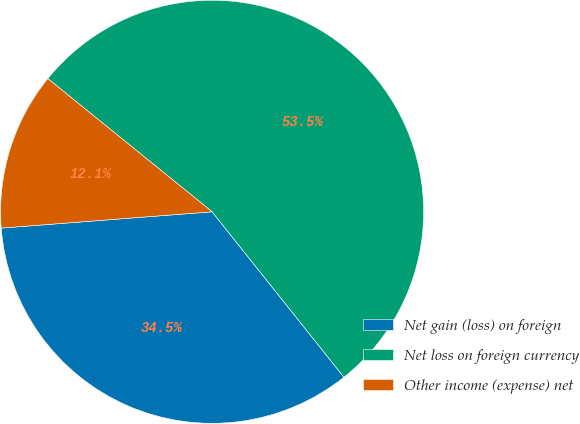<chart> <loc_0><loc_0><loc_500><loc_500><pie_chart><fcel>Net gain (loss) on foreign<fcel>Net loss on foreign currency<fcel>Other income (expense) net<nl><fcel>34.48%<fcel>53.45%<fcel>12.07%<nl></chart> 